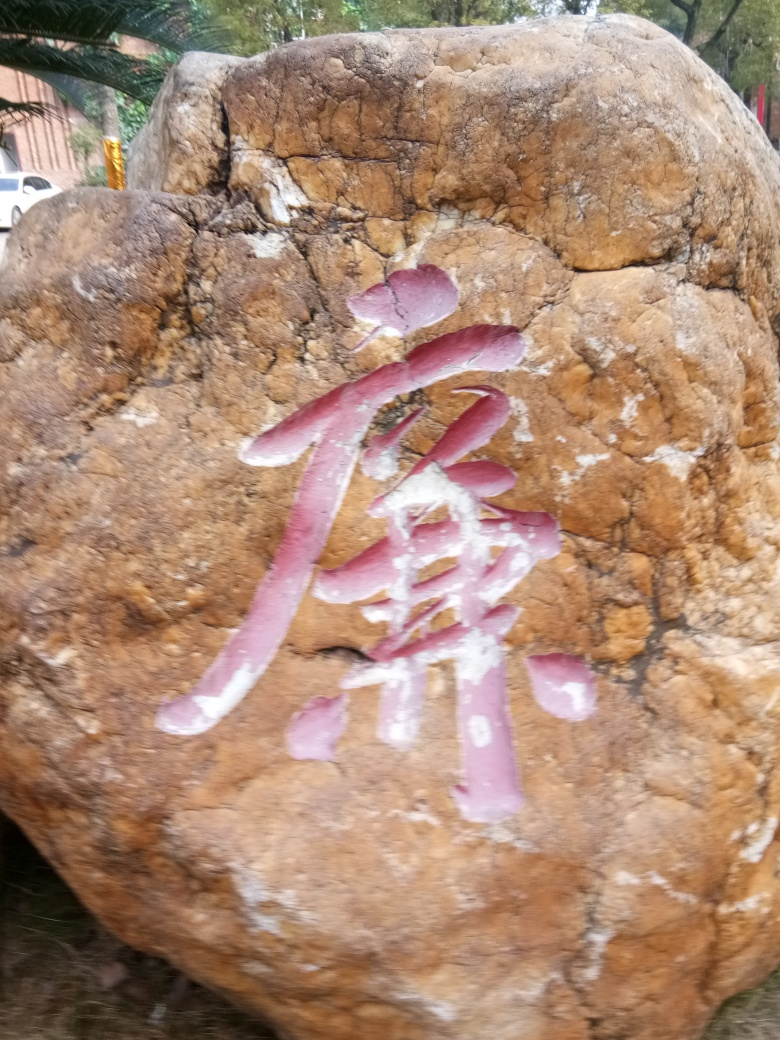Can you describe what is shown on the rock? The image displays a large rock with what appears to be a character or symbol painted in a faded pink color. The character is potentially of Asian origin, perhaps Chinese or Japanese, however, due to the quality of the photo, specifics about its meaning or context cannot be accurately determined. 